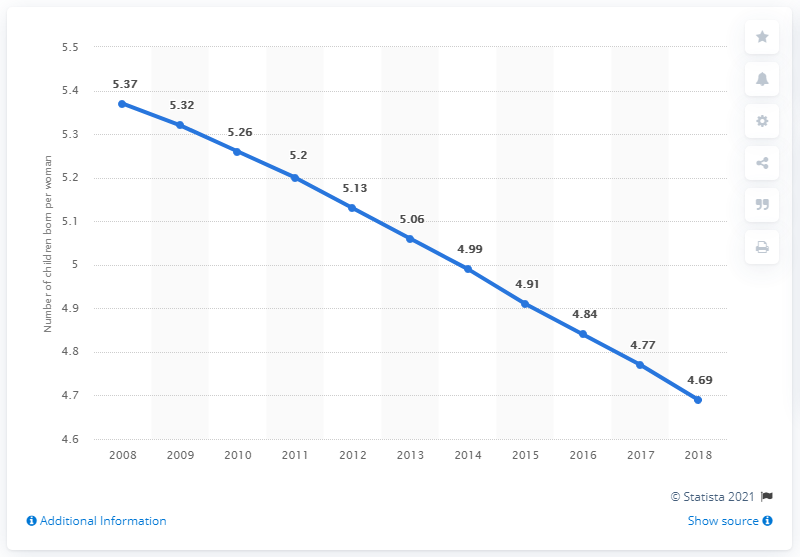Specify some key components in this picture. In 2018, the fertility rate in Sub-Saharan Africa was 4.69, which represents a slight decrease from previous years. 